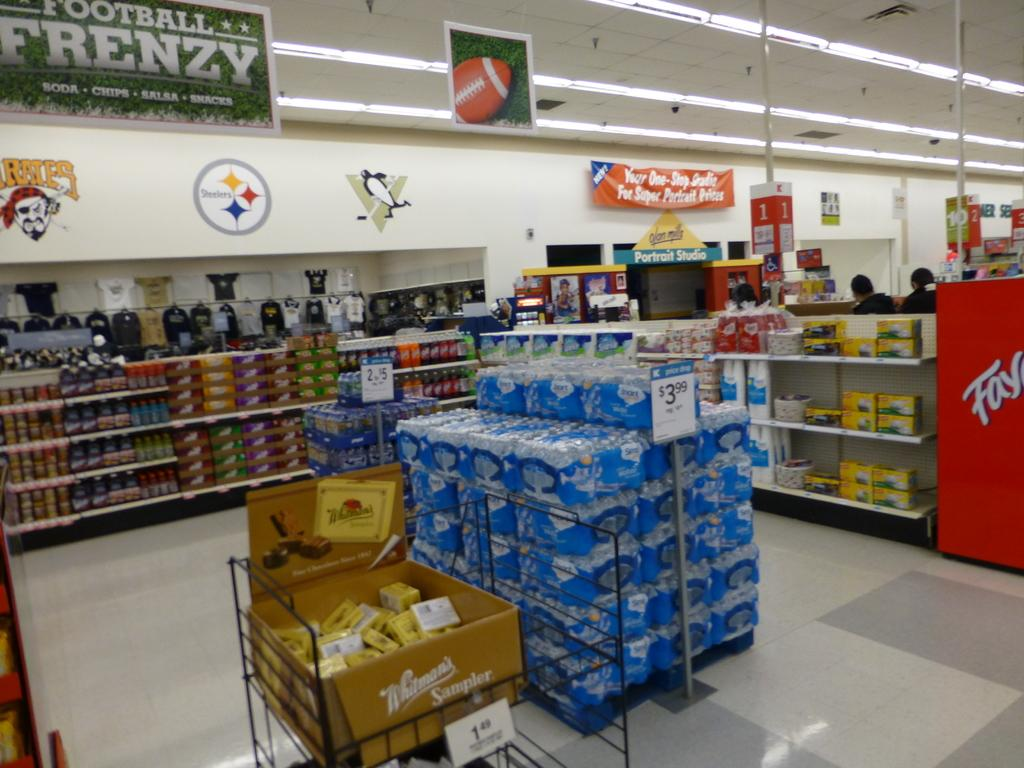<image>
Relay a brief, clear account of the picture shown. A Football Frenzy banner hangs high on the wall of a grocery store. 